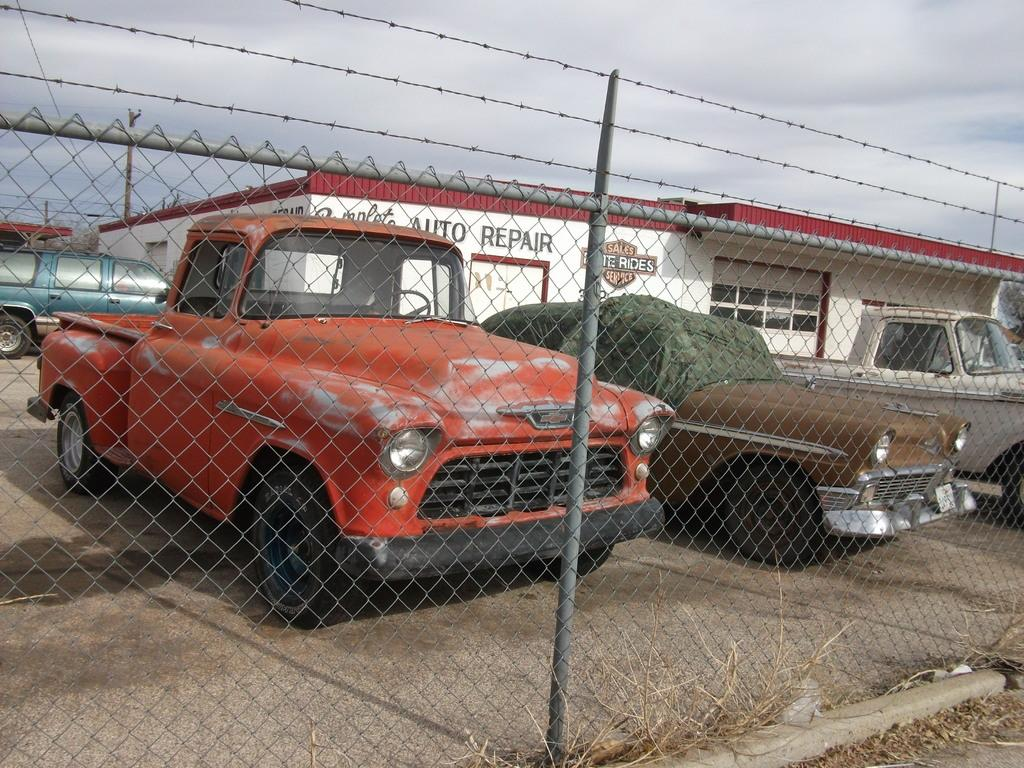What types of vehicles can be seen in the image? There are different colors and models of vehicles in the image. How are the vehicles positioned in relation to the image? The vehicles are behind fencing. What structure can be seen in the background of the image? There is a garage visible in the background of the image. What type of nail is being used to fix the daughter's fight in the image? There is no nail, daughter, or fight present in the image. 